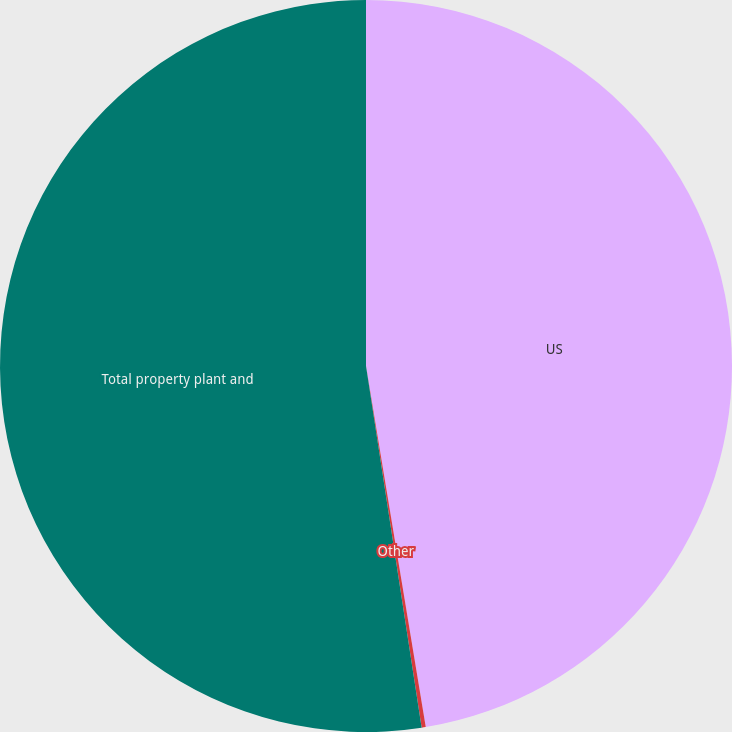<chart> <loc_0><loc_0><loc_500><loc_500><pie_chart><fcel>US<fcel>Other<fcel>Total property plant and<nl><fcel>47.39%<fcel>0.18%<fcel>52.43%<nl></chart> 